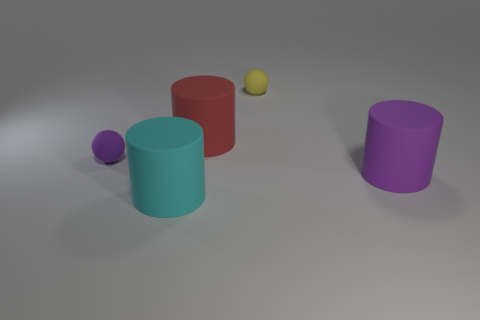There is a large red object that is the same shape as the large purple thing; what is its material?
Ensure brevity in your answer.  Rubber. Are there any cyan rubber objects behind the rubber thing on the left side of the matte cylinder on the left side of the big red cylinder?
Provide a succinct answer. No. How many tiny matte spheres are both to the left of the red cylinder and to the right of the tiny purple ball?
Keep it short and to the point. 0. There is a cyan matte object; what shape is it?
Offer a very short reply. Cylinder. What number of other things are the same material as the large purple object?
Keep it short and to the point. 4. The large cylinder that is in front of the rubber cylinder that is right of the rubber object that is behind the red rubber thing is what color?
Your response must be concise. Cyan. There is a yellow thing that is the same size as the purple sphere; what material is it?
Your answer should be very brief. Rubber. How many objects are either rubber things that are on the left side of the small yellow object or big matte things?
Your response must be concise. 4. Are any small yellow balls visible?
Ensure brevity in your answer.  Yes. What material is the large cylinder on the right side of the yellow matte ball?
Keep it short and to the point. Rubber. 